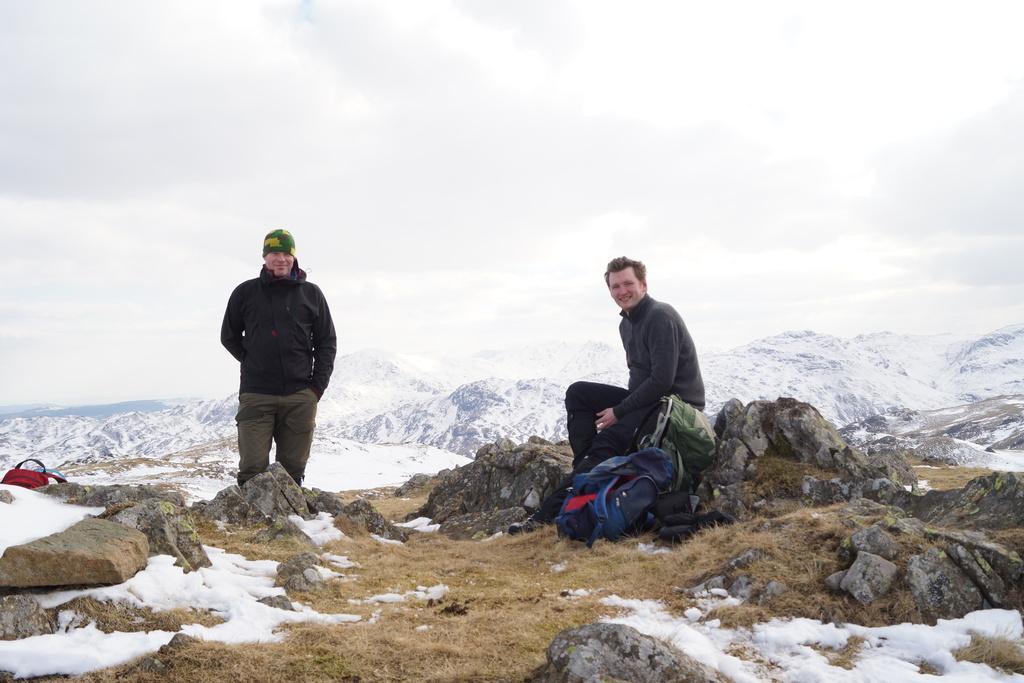How would you summarize this image in a sentence or two? There is a person standing and wearing a cap and also a person is sitting on rocks. Near to him there are bags. There are rocks. In the back there are small hills covered with snow. Also there is sky. 